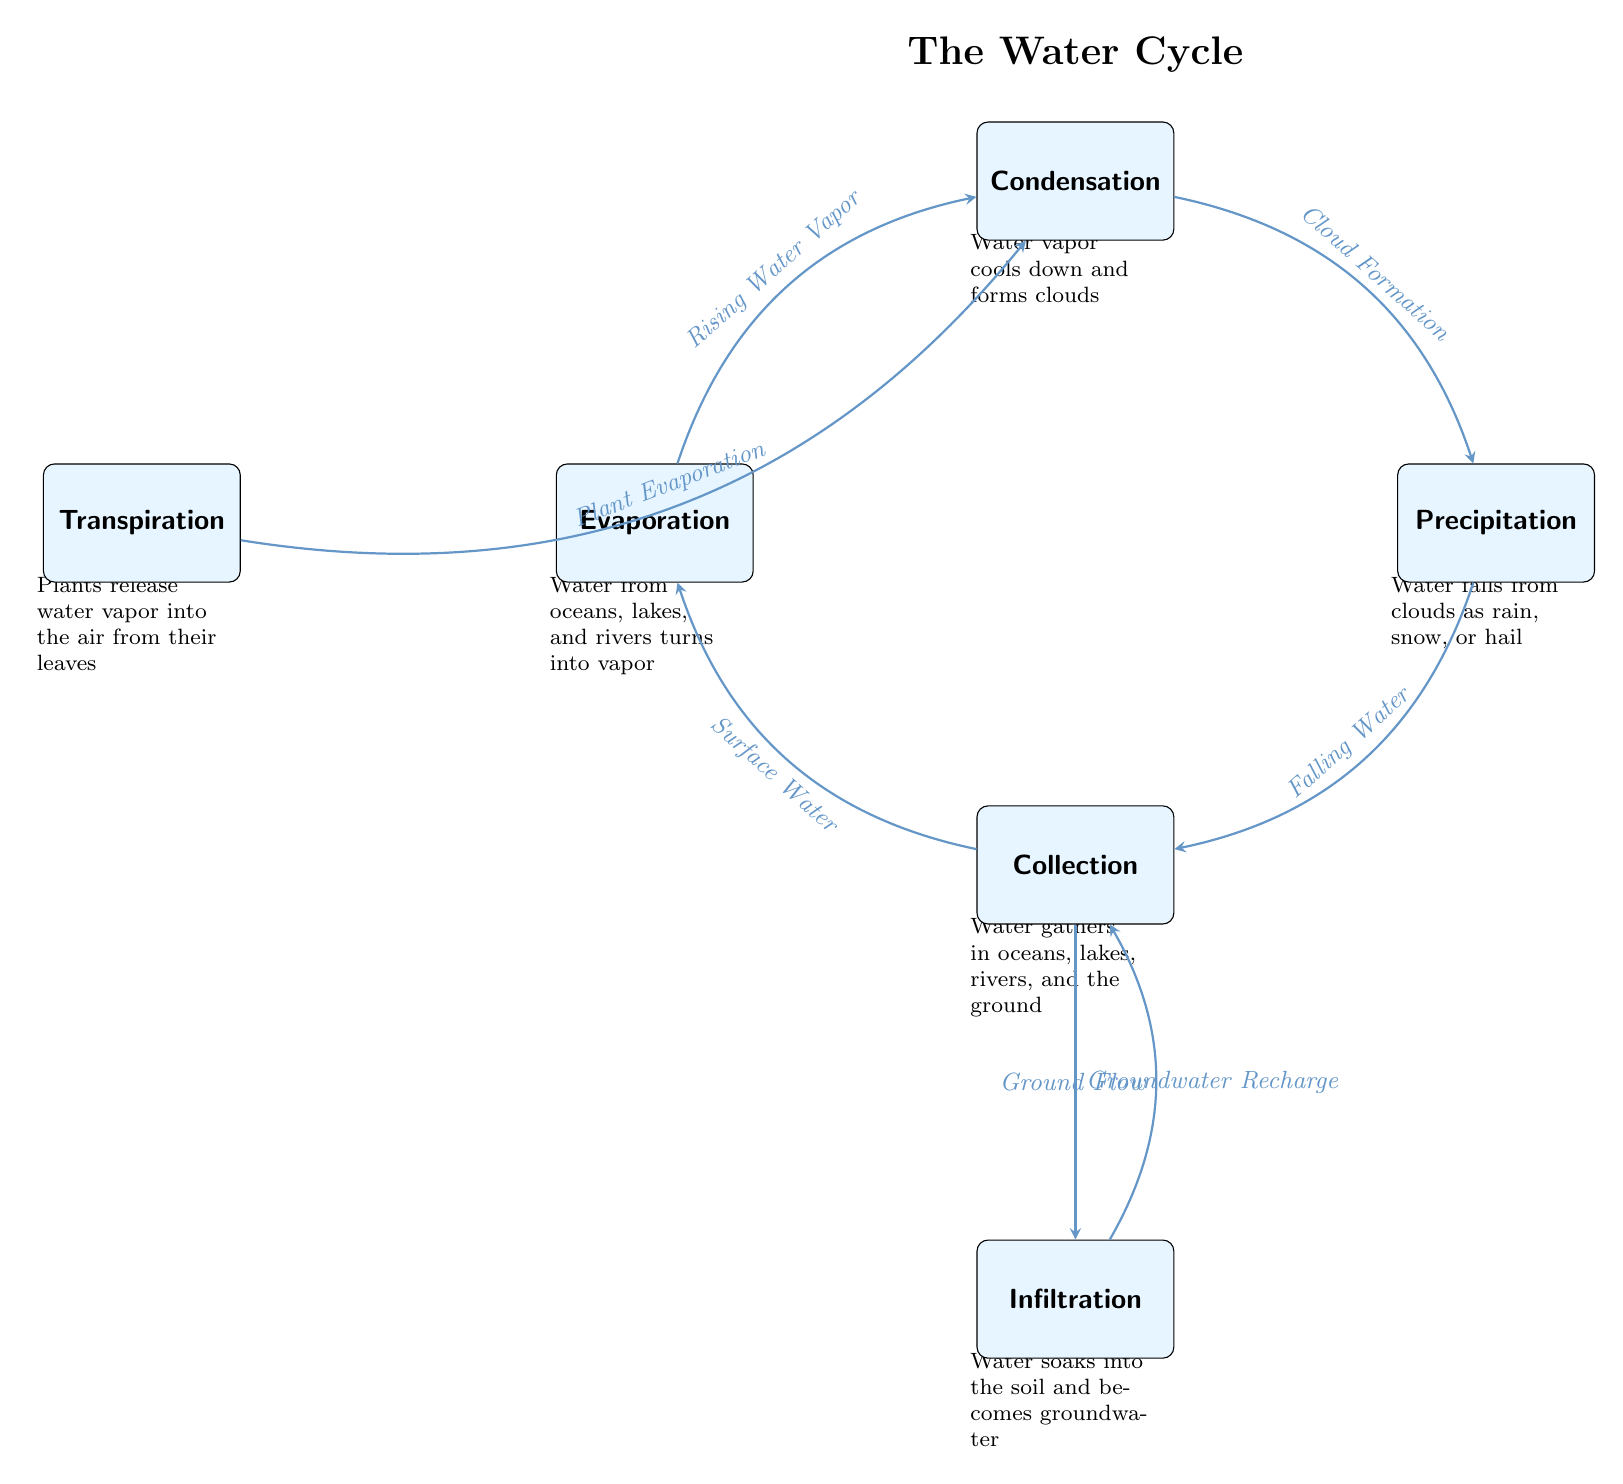What is the first stage of the water cycle? The first stage of the water cycle is indicated at the top of the diagram and is labeled as "Evaporation," which represents the process where water turns into vapor.
Answer: Evaporation How many main stages are represented in the water cycle diagram? In the water cycle diagram, there are six main stages represented: Evaporation, Condensation, Precipitation, Collection, Infiltration, and Transpiration.
Answer: 6 What is the process that occurs after condensation? The diagram shows that the process that follows condensation is labeled as "Precipitation," where water falls from clouds.
Answer: Precipitation What type of water movement occurs from collection to infiltration? According to the diagram, the movement from collection to infiltration is labeled as "Groundwater Recharge," indicating that water moves into the ground.
Answer: Groundwater Recharge Where does transpiration lead to in the water cycle? In the flow of the diagram, transpiration leads to condensation, as indicated by the arrow connecting these two stages.
Answer: Condensation What happens to water vapor during condensation? The background explanation for condensation states that water vapor cools down and forms clouds during this stage.
Answer: Forms clouds Explain the connection between precipitation and collection. The diagram shows that precipitation leads directly to collection, indicated by an arrow labeled "Falling Water," meaning that water accumulates in bodies of water after it falls.
Answer: Collection What is the source of the "Rising Water Vapor"? The diagram shows that "Rising Water Vapor" originates from the process of "Evaporation," which is where water turns into vapor from oceans, lakes, and rivers.
Answer: Evaporation How does groundwater return to the collection stage? The diagram indicates that groundwater returns to the collection stage through a process labeled "Ground Flow," connecting infiltration back to collection.
Answer: Ground Flow 